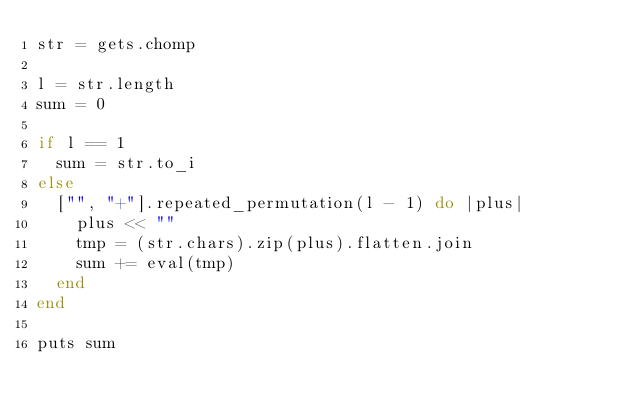<code> <loc_0><loc_0><loc_500><loc_500><_Ruby_>str = gets.chomp

l = str.length
sum = 0

if l == 1
  sum = str.to_i
else
  ["", "+"].repeated_permutation(l - 1) do |plus|
    plus << ""
    tmp = (str.chars).zip(plus).flatten.join
    sum += eval(tmp)
  end
end

puts sum</code> 